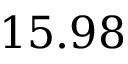<formula> <loc_0><loc_0><loc_500><loc_500>1 5 . 9 8</formula> 